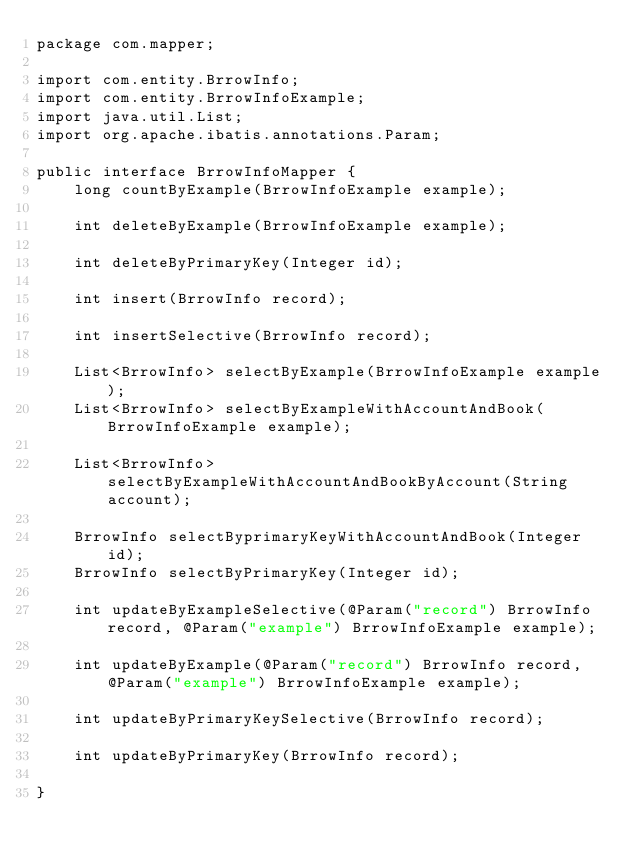<code> <loc_0><loc_0><loc_500><loc_500><_Java_>package com.mapper;

import com.entity.BrrowInfo;
import com.entity.BrrowInfoExample;
import java.util.List;
import org.apache.ibatis.annotations.Param;

public interface BrrowInfoMapper {
    long countByExample(BrrowInfoExample example);

    int deleteByExample(BrrowInfoExample example);

    int deleteByPrimaryKey(Integer id);

    int insert(BrrowInfo record);

    int insertSelective(BrrowInfo record);

    List<BrrowInfo> selectByExample(BrrowInfoExample example);
    List<BrrowInfo> selectByExampleWithAccountAndBook(BrrowInfoExample example);

    List<BrrowInfo> selectByExampleWithAccountAndBookByAccount(String account);

    BrrowInfo selectByprimaryKeyWithAccountAndBook(Integer id);
    BrrowInfo selectByPrimaryKey(Integer id);

    int updateByExampleSelective(@Param("record") BrrowInfo record, @Param("example") BrrowInfoExample example);

    int updateByExample(@Param("record") BrrowInfo record, @Param("example") BrrowInfoExample example);

    int updateByPrimaryKeySelective(BrrowInfo record);

    int updateByPrimaryKey(BrrowInfo record);

}</code> 